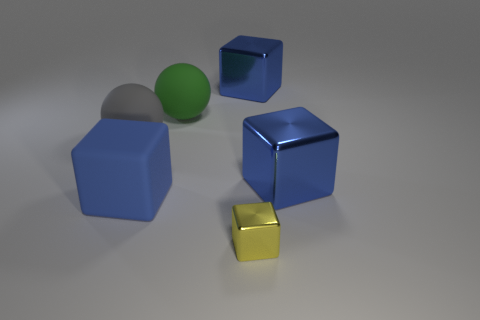There is a gray thing; is its size the same as the blue metallic thing that is in front of the gray thing?
Offer a terse response. Yes. What number of small things are yellow metallic cubes or green objects?
Provide a succinct answer. 1. Is the number of tiny yellow shiny objects greater than the number of purple blocks?
Ensure brevity in your answer.  Yes. How many big things are in front of the large shiny object in front of the big shiny block that is left of the small yellow metallic block?
Give a very brief answer. 1. What shape is the big green rubber thing?
Your response must be concise. Sphere. How many other objects are the same material as the big gray ball?
Your response must be concise. 2. Do the yellow shiny object and the gray matte sphere have the same size?
Your answer should be compact. No. What is the shape of the big shiny object that is in front of the large gray matte ball?
Offer a terse response. Cube. What color is the big matte sphere behind the big rubber ball to the left of the rubber block?
Provide a succinct answer. Green. Does the blue shiny object in front of the large gray object have the same shape as the large rubber thing behind the gray sphere?
Make the answer very short. No. 